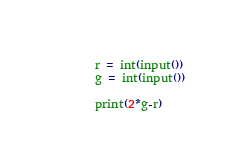<code> <loc_0><loc_0><loc_500><loc_500><_Python_>r = int(input())
g = int(input())

print(2*g-r)
</code> 